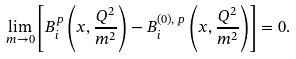Convert formula to latex. <formula><loc_0><loc_0><loc_500><loc_500>\lim _ { m \rightarrow 0 } \left [ B ^ { p } _ { i } \left ( x , \frac { Q ^ { 2 } } { m ^ { 2 } } \right ) - B ^ { ( 0 ) , \, p } _ { i } \left ( x , \frac { Q ^ { 2 } } { m ^ { 2 } } \right ) \right ] = 0 .</formula> 